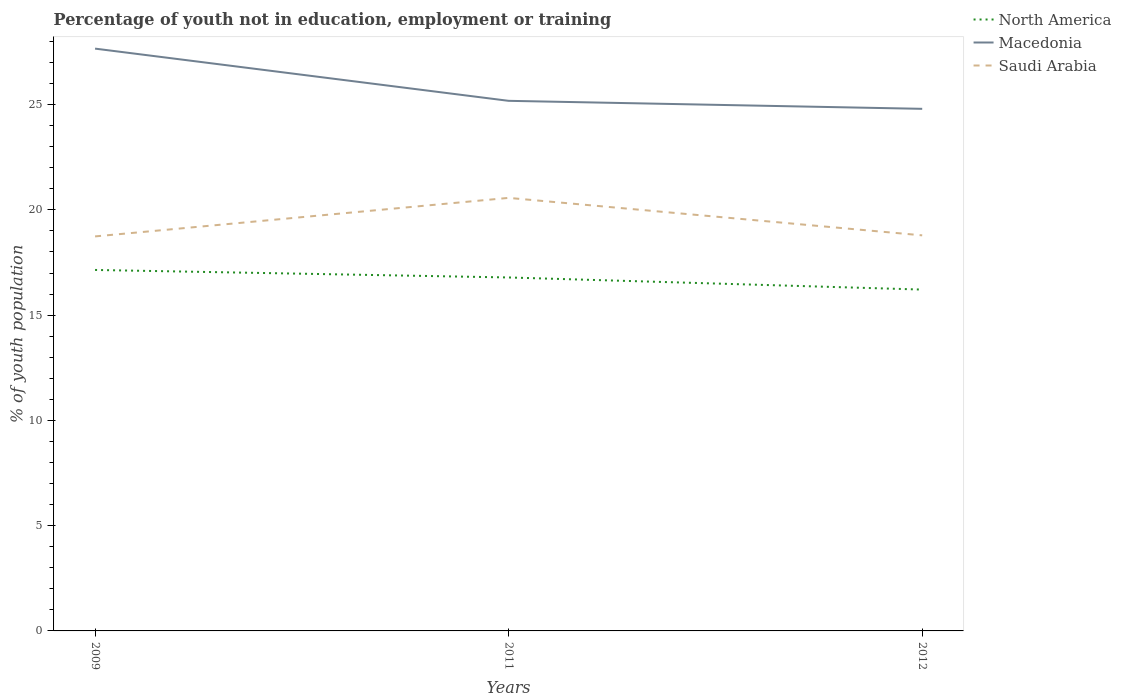How many different coloured lines are there?
Your response must be concise. 3. Across all years, what is the maximum percentage of unemployed youth population in in Macedonia?
Make the answer very short. 24.8. In which year was the percentage of unemployed youth population in in Saudi Arabia maximum?
Offer a terse response. 2009. What is the total percentage of unemployed youth population in in Macedonia in the graph?
Offer a very short reply. 0.38. What is the difference between the highest and the second highest percentage of unemployed youth population in in Macedonia?
Your answer should be very brief. 2.86. What is the difference between the highest and the lowest percentage of unemployed youth population in in North America?
Keep it short and to the point. 2. Is the percentage of unemployed youth population in in Saudi Arabia strictly greater than the percentage of unemployed youth population in in Macedonia over the years?
Offer a very short reply. Yes. How many years are there in the graph?
Offer a very short reply. 3. What is the difference between two consecutive major ticks on the Y-axis?
Keep it short and to the point. 5. Are the values on the major ticks of Y-axis written in scientific E-notation?
Provide a short and direct response. No. How are the legend labels stacked?
Offer a very short reply. Vertical. What is the title of the graph?
Keep it short and to the point. Percentage of youth not in education, employment or training. Does "San Marino" appear as one of the legend labels in the graph?
Give a very brief answer. No. What is the label or title of the X-axis?
Offer a terse response. Years. What is the label or title of the Y-axis?
Offer a terse response. % of youth population. What is the % of youth population in North America in 2009?
Offer a terse response. 17.15. What is the % of youth population in Macedonia in 2009?
Provide a short and direct response. 27.66. What is the % of youth population in Saudi Arabia in 2009?
Your answer should be compact. 18.74. What is the % of youth population of North America in 2011?
Your answer should be very brief. 16.79. What is the % of youth population in Macedonia in 2011?
Your answer should be very brief. 25.18. What is the % of youth population in Saudi Arabia in 2011?
Provide a succinct answer. 20.57. What is the % of youth population of North America in 2012?
Offer a very short reply. 16.21. What is the % of youth population in Macedonia in 2012?
Offer a terse response. 24.8. What is the % of youth population in Saudi Arabia in 2012?
Make the answer very short. 18.79. Across all years, what is the maximum % of youth population of North America?
Provide a succinct answer. 17.15. Across all years, what is the maximum % of youth population of Macedonia?
Offer a very short reply. 27.66. Across all years, what is the maximum % of youth population of Saudi Arabia?
Offer a very short reply. 20.57. Across all years, what is the minimum % of youth population of North America?
Your response must be concise. 16.21. Across all years, what is the minimum % of youth population of Macedonia?
Your answer should be compact. 24.8. Across all years, what is the minimum % of youth population in Saudi Arabia?
Provide a short and direct response. 18.74. What is the total % of youth population of North America in the graph?
Make the answer very short. 50.15. What is the total % of youth population in Macedonia in the graph?
Give a very brief answer. 77.64. What is the total % of youth population in Saudi Arabia in the graph?
Provide a short and direct response. 58.1. What is the difference between the % of youth population in North America in 2009 and that in 2011?
Ensure brevity in your answer.  0.36. What is the difference between the % of youth population in Macedonia in 2009 and that in 2011?
Make the answer very short. 2.48. What is the difference between the % of youth population in Saudi Arabia in 2009 and that in 2011?
Provide a short and direct response. -1.83. What is the difference between the % of youth population in North America in 2009 and that in 2012?
Make the answer very short. 0.93. What is the difference between the % of youth population of Macedonia in 2009 and that in 2012?
Your answer should be very brief. 2.86. What is the difference between the % of youth population in Saudi Arabia in 2009 and that in 2012?
Provide a succinct answer. -0.05. What is the difference between the % of youth population of North America in 2011 and that in 2012?
Give a very brief answer. 0.58. What is the difference between the % of youth population in Macedonia in 2011 and that in 2012?
Offer a very short reply. 0.38. What is the difference between the % of youth population of Saudi Arabia in 2011 and that in 2012?
Your answer should be compact. 1.78. What is the difference between the % of youth population of North America in 2009 and the % of youth population of Macedonia in 2011?
Offer a very short reply. -8.03. What is the difference between the % of youth population of North America in 2009 and the % of youth population of Saudi Arabia in 2011?
Keep it short and to the point. -3.42. What is the difference between the % of youth population in Macedonia in 2009 and the % of youth population in Saudi Arabia in 2011?
Your answer should be very brief. 7.09. What is the difference between the % of youth population in North America in 2009 and the % of youth population in Macedonia in 2012?
Offer a very short reply. -7.65. What is the difference between the % of youth population of North America in 2009 and the % of youth population of Saudi Arabia in 2012?
Provide a succinct answer. -1.64. What is the difference between the % of youth population in Macedonia in 2009 and the % of youth population in Saudi Arabia in 2012?
Keep it short and to the point. 8.87. What is the difference between the % of youth population in North America in 2011 and the % of youth population in Macedonia in 2012?
Give a very brief answer. -8.01. What is the difference between the % of youth population of North America in 2011 and the % of youth population of Saudi Arabia in 2012?
Your response must be concise. -2. What is the difference between the % of youth population of Macedonia in 2011 and the % of youth population of Saudi Arabia in 2012?
Give a very brief answer. 6.39. What is the average % of youth population in North America per year?
Keep it short and to the point. 16.72. What is the average % of youth population of Macedonia per year?
Make the answer very short. 25.88. What is the average % of youth population of Saudi Arabia per year?
Provide a succinct answer. 19.37. In the year 2009, what is the difference between the % of youth population of North America and % of youth population of Macedonia?
Your response must be concise. -10.51. In the year 2009, what is the difference between the % of youth population of North America and % of youth population of Saudi Arabia?
Your answer should be compact. -1.59. In the year 2009, what is the difference between the % of youth population of Macedonia and % of youth population of Saudi Arabia?
Offer a very short reply. 8.92. In the year 2011, what is the difference between the % of youth population in North America and % of youth population in Macedonia?
Ensure brevity in your answer.  -8.39. In the year 2011, what is the difference between the % of youth population in North America and % of youth population in Saudi Arabia?
Your response must be concise. -3.78. In the year 2011, what is the difference between the % of youth population in Macedonia and % of youth population in Saudi Arabia?
Your answer should be very brief. 4.61. In the year 2012, what is the difference between the % of youth population in North America and % of youth population in Macedonia?
Make the answer very short. -8.59. In the year 2012, what is the difference between the % of youth population in North America and % of youth population in Saudi Arabia?
Your response must be concise. -2.58. In the year 2012, what is the difference between the % of youth population of Macedonia and % of youth population of Saudi Arabia?
Give a very brief answer. 6.01. What is the ratio of the % of youth population of North America in 2009 to that in 2011?
Ensure brevity in your answer.  1.02. What is the ratio of the % of youth population in Macedonia in 2009 to that in 2011?
Provide a short and direct response. 1.1. What is the ratio of the % of youth population of Saudi Arabia in 2009 to that in 2011?
Your answer should be very brief. 0.91. What is the ratio of the % of youth population of North America in 2009 to that in 2012?
Provide a short and direct response. 1.06. What is the ratio of the % of youth population in Macedonia in 2009 to that in 2012?
Provide a short and direct response. 1.12. What is the ratio of the % of youth population of North America in 2011 to that in 2012?
Your response must be concise. 1.04. What is the ratio of the % of youth population in Macedonia in 2011 to that in 2012?
Your answer should be very brief. 1.02. What is the ratio of the % of youth population of Saudi Arabia in 2011 to that in 2012?
Your answer should be compact. 1.09. What is the difference between the highest and the second highest % of youth population in North America?
Offer a terse response. 0.36. What is the difference between the highest and the second highest % of youth population in Macedonia?
Your answer should be very brief. 2.48. What is the difference between the highest and the second highest % of youth population in Saudi Arabia?
Make the answer very short. 1.78. What is the difference between the highest and the lowest % of youth population of North America?
Ensure brevity in your answer.  0.93. What is the difference between the highest and the lowest % of youth population of Macedonia?
Your answer should be very brief. 2.86. What is the difference between the highest and the lowest % of youth population of Saudi Arabia?
Make the answer very short. 1.83. 